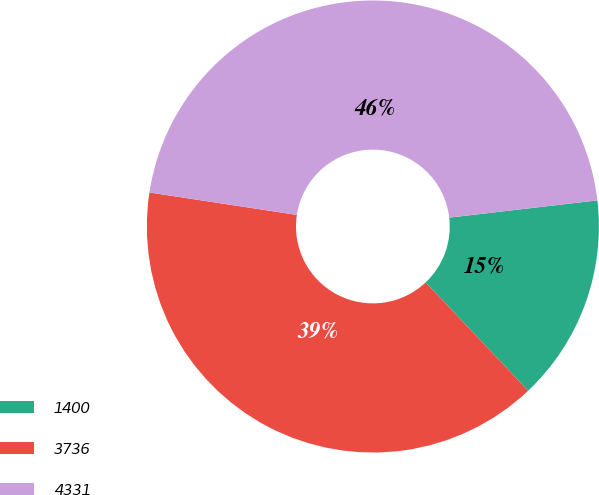<chart> <loc_0><loc_0><loc_500><loc_500><pie_chart><fcel>1400<fcel>3736<fcel>4331<nl><fcel>14.79%<fcel>39.46%<fcel>45.75%<nl></chart> 